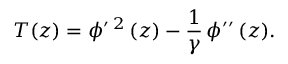<formula> <loc_0><loc_0><loc_500><loc_500>T ( z ) = \phi ^ { \prime } \, ^ { 2 } \, ( z ) - \frac { 1 } { \gamma } \, \phi ^ { \prime \prime } \, ( z ) .</formula> 